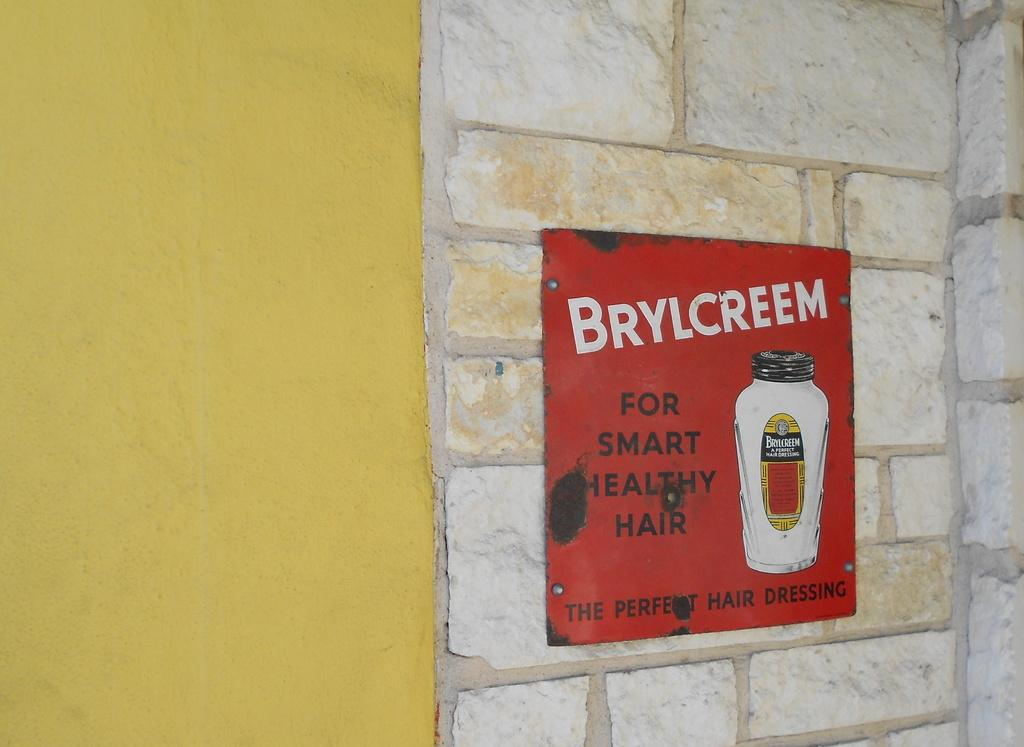<image>
Relay a brief, clear account of the picture shown. a sign on a wall that says 'brylcreem for smart healthy hair the perfect hair dressing' on it 